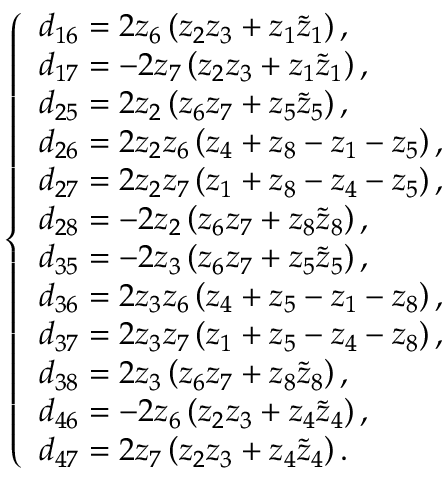Convert formula to latex. <formula><loc_0><loc_0><loc_500><loc_500>\left \{ \begin{array} { l l } { d _ { 1 6 } = 2 z _ { 6 } \left ( z _ { 2 } z _ { 3 } + z _ { 1 } \tilde { z } _ { 1 } \right ) , } \\ { d _ { 1 7 } = - 2 z _ { 7 } \left ( z _ { 2 } z _ { 3 } + z _ { 1 } \tilde { z } _ { 1 } \right ) , } \\ { d _ { 2 5 } = 2 z _ { 2 } \left ( z _ { 6 } z _ { 7 } + z _ { 5 } \tilde { z } _ { 5 } \right ) , } \\ { d _ { 2 6 } = 2 z _ { 2 } z _ { 6 } \left ( z _ { 4 } + z _ { 8 } - z _ { 1 } - z _ { 5 } \right ) , } \\ { d _ { 2 7 } = 2 z _ { 2 } z _ { 7 } \left ( z _ { 1 } + z _ { 8 } - z _ { 4 } - z _ { 5 } \right ) , } \\ { d _ { 2 8 } = - 2 z _ { 2 } \left ( z _ { 6 } z _ { 7 } + z _ { 8 } \tilde { z } _ { 8 } \right ) , } \\ { d _ { 3 5 } = - 2 z _ { 3 } \left ( z _ { 6 } z _ { 7 } + z _ { 5 } \tilde { z } _ { 5 } \right ) , } \\ { d _ { 3 6 } = 2 z _ { 3 } z _ { 6 } \left ( z _ { 4 } + z _ { 5 } - z _ { 1 } - z _ { 8 } \right ) , } \\ { d _ { 3 7 } = 2 z _ { 3 } z _ { 7 } \left ( z _ { 1 } + z _ { 5 } - z _ { 4 } - z _ { 8 } \right ) , } \\ { d _ { 3 8 } = 2 z _ { 3 } \left ( z _ { 6 } z _ { 7 } + z _ { 8 } \tilde { z } _ { 8 } \right ) , } \\ { d _ { 4 6 } = - 2 z _ { 6 } \left ( z _ { 2 } z _ { 3 } + z _ { 4 } \tilde { z } _ { 4 } \right ) , } \\ { d _ { 4 7 } = 2 z _ { 7 } \left ( z _ { 2 } z _ { 3 } + z _ { 4 } \tilde { z } _ { 4 } \right ) . } \end{array}</formula> 